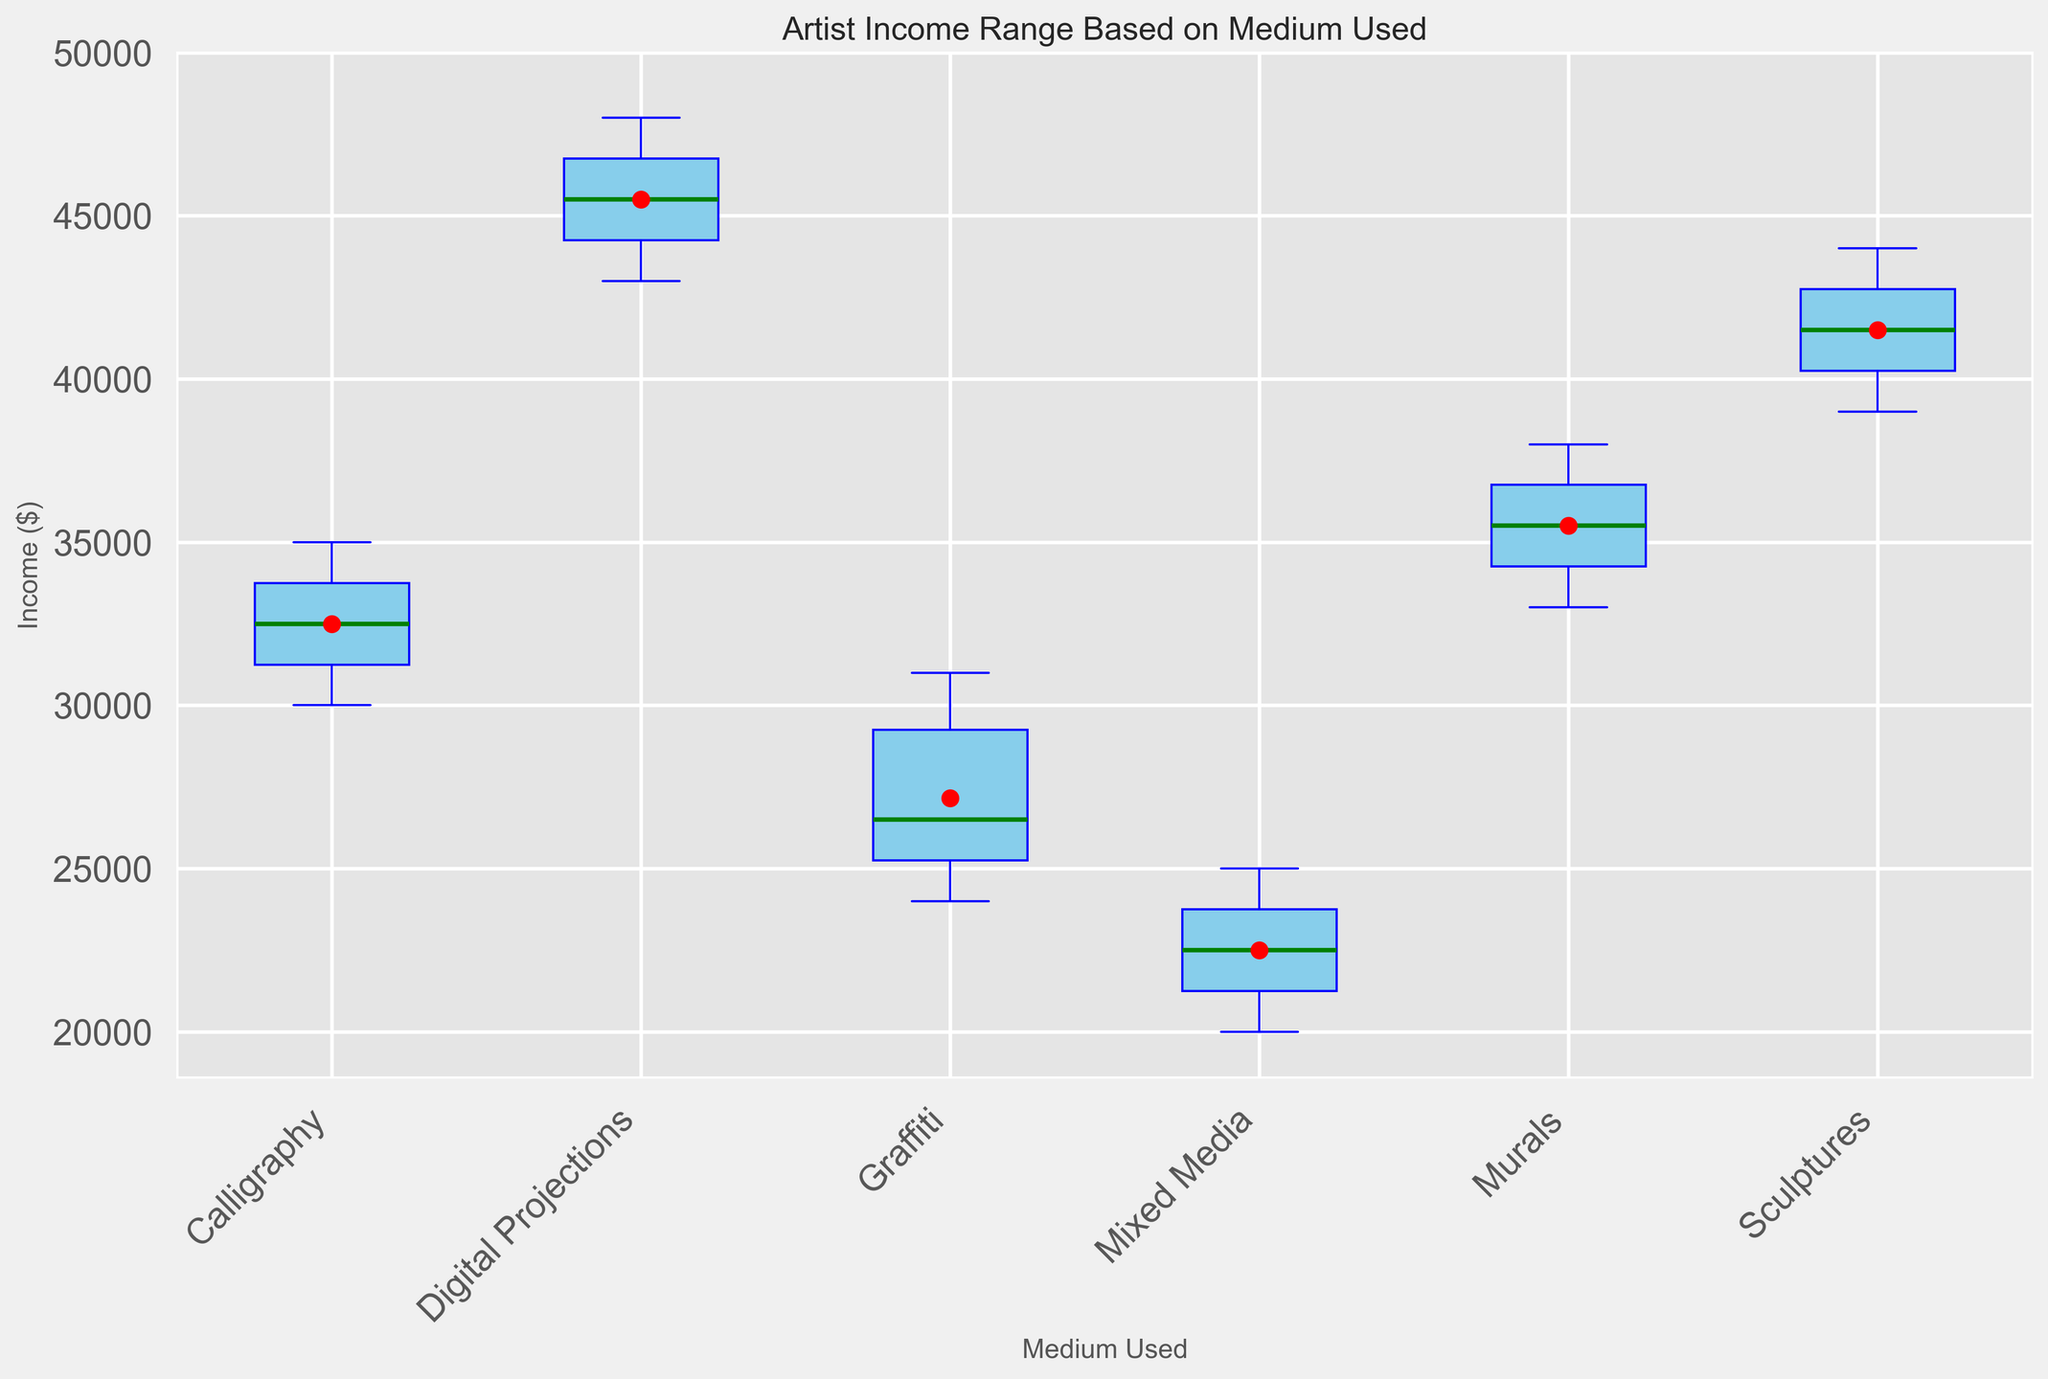What is the median income for artists using Murals? The centerline within the box for Murals represents the median value. By visually inspecting the plot, this centerline is around $35,000.
Answer: $35,000 Which medium has the highest mean income? The mean is represented by a red circle within each box plot. By comparing the positions of the red circles, Digital Projections has the highest mean income, around $45,000.
Answer: Digital Projections What is the minimum income recorded for Mixed Media? The minimum value is indicated by the lowest point of the whisker for Mixed Media. This position corresponds to an income of $20,000.
Answer: $20,000 Compare the range of incomes for Sculptures and Graffiti. Which one has a larger range? The range is the difference between the maximum value (top whisker) and the minimum value (bottom whisker). For Sculptures, the range is from $39,000 to $44,000, which is $5,000. For Graffiti, it ranges from $24,000 to $31,000, which is $7,000. Therefore, Graffiti has a larger range.
Answer: Graffiti Identify the medium with the narrowest income range. The narrowest range will have the smallest distance between the lowest and highest whiskers. By visually inspecting the plot, Calligraphy has the narrowest range from $30,000 to $35,000, which is $5,000.
Answer: Calligraphy Which medium has the largest interquartile range (IQR)? The IQR is the length of the box, calculated as the difference between the upper quartile (top of the box) and the lower quartile (bottom of the box). By visual inspection, Graffiti has the widest box, indicating the largest IQR.
Answer: Graffiti How do the median incomes of Calligraphy and Murals compare? The median is the centerline within each box plot. Visually, the median for Murals is around $35,000, and for Calligraphy, it is around $32,000. Therefore, Murals has a higher median income.
Answer: Murals Which medium shows the highest variability in income? Variability can be judged by the overall spread of data (distance between whiskers). Graffiti shows the highest spread from $24,000 to $31,000, indicating high variability.
Answer: Graffiti What is the mean income for artists using Mixed Media? The mean is indicated by a red circle within each box plot. By referencing the plot, the mean income for Mixed Media is around $23,000.
Answer: $23,000 